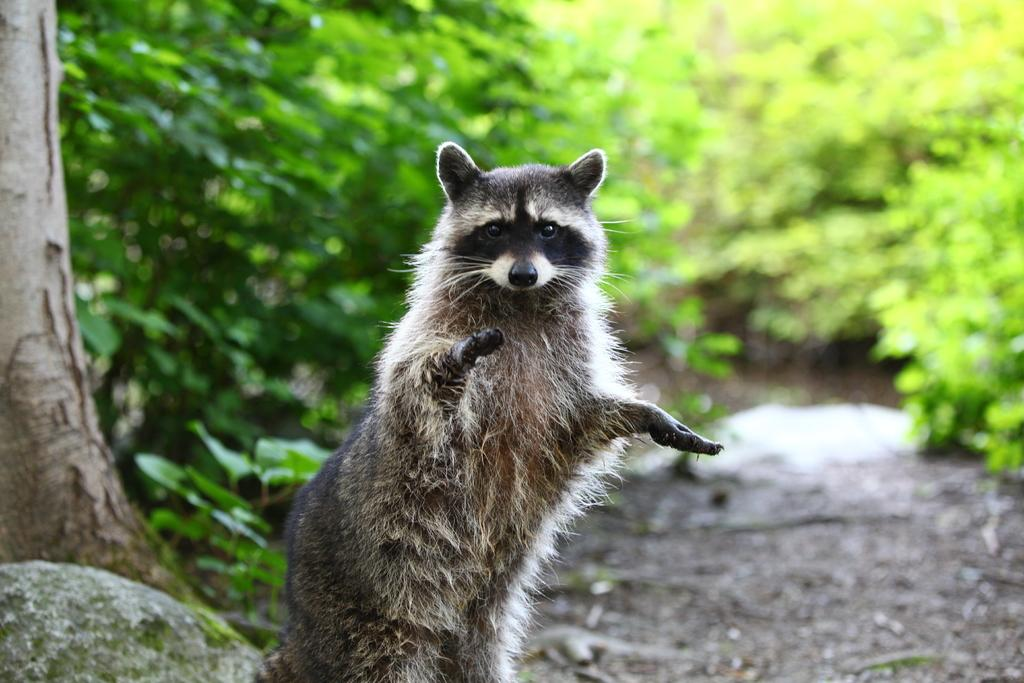What type of creature can be seen in the image? There is an animal in the picture. Where is the animal positioned in relation to other objects in the image? The animal is standing beside a rock. What other natural elements are present in the image? There is a tree in the picture, and plants are visible behind the animal. What statement or request is the animal making in the image? There is no indication in the image that the animal is making a statement or request, as animals do not have the ability to communicate in this manner. 